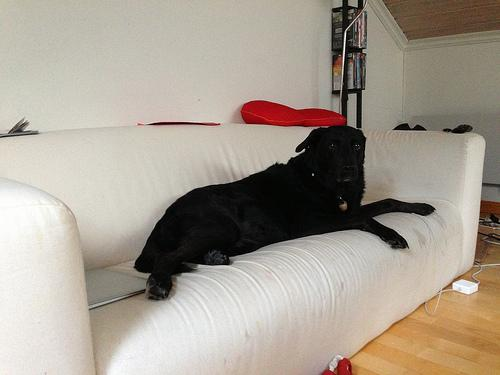Analyze the interaction between the black dog and its surroundings. The black dog is peacefully laying down on the white couch, enjoying its comfort and not engaging with any items around it. Count the number of visible dog paws in the image. Four dog paws are visible in the image. How would you rate the quality of this image, using terms such as 'excellent', 'good', 'fair', or 'poor'?  The image quality can be considered as good. Provide a concise description of the image's contents. The image features a black dog relaxing on a white couch with a red pillow, a laptop, and various other items in the background. What is the primary focus of the image? A black dog laying down on a white couch with a red pillow. Is there any electronic device visible in the image? If yes, what is it? Yes, there is a laptop on the couch. What might be the overall mood or sentiment of this image? The image exudes a calm and relaxed atmosphere, with the dog enjoying its rest on the couch. Can you find any indications that the dog may be a pet or owned by someone? Yes, the dog is wearing a collar, which may indicate that it is a pet or owned by someone. What color is the pillow on the couch and where is it located? The pillow is red and located on the white couch. Describe the placement of objects in the image, such as on the floor, couch, or wall. A black dog, red pillow, and laptop are on the couch; wires and power cord are on the floor; a black shelf and dvds are on the wall and shelf, respectively. 